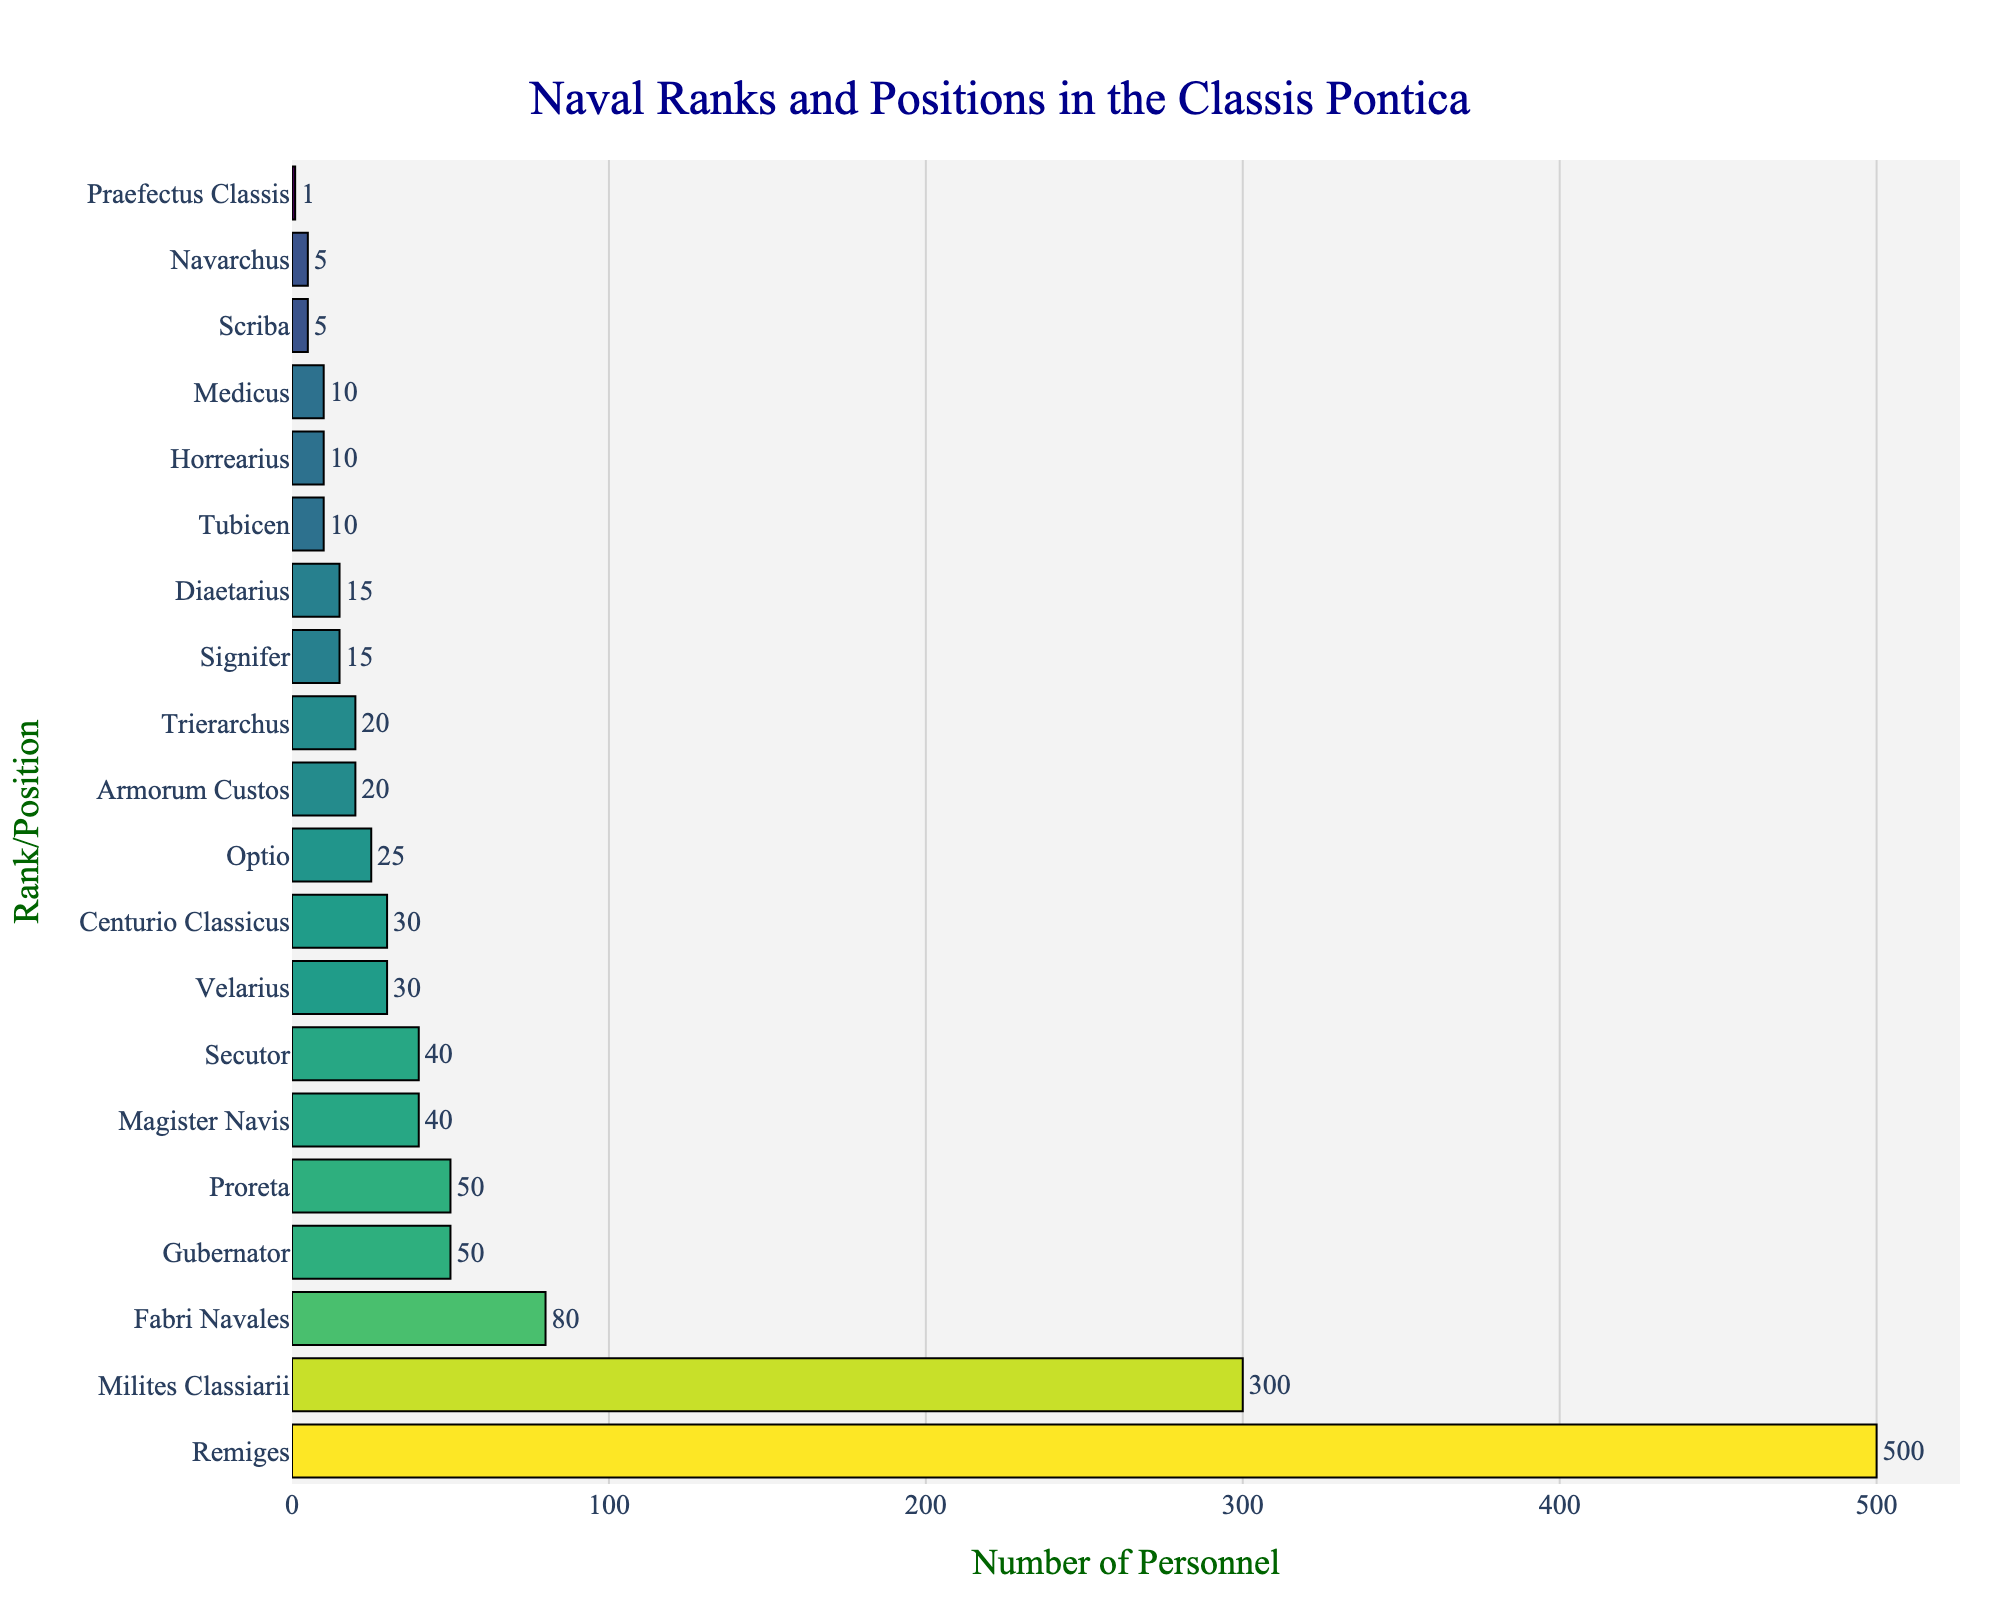What rank/position has the highest number of personnel? By looking at the lengths of the bars, the longest bar represents the rank/position with the highest number of personnel.
Answer: Remiges What is the total number of personnel represented in the chart? Summing up all the values from the different ranks/positions: 1 + 5 + 20 + 30 + 50 + 50 + 40 + 500 + 300 + 80 + 10 + 15 + 10 + 25 + 40 + 30 + 20 + 15 + 10 + 5 = 1,256.
Answer: 1,256 How many ranks/positions have fewer than 20 personnel? Identify the bars that correspond to values less than 20 and count them: Praefectus Classis (1), Scriba (5), Navarchus (5), Diaetarius (15), Signifer (15), and Medicus (10). These total 6 ranks/positions.
Answer: 6 Which rank/position has the closest number of personnel to that of the Gubernator? The Gubernator has 50 personnel. The two ranks/positions with personnel close to this number are Proreta (50) and Magister Navis (40). Since Proreta has the same number, it's the rank/position closest.
Answer: Proreta What is the average number of personnel for the ranks/positions with more than 100 personnel? Identify ranks/positions with more than 100 personnel: Remiges (500) and Milites Classiarii (300). Calculate the average: (500 + 300) / 2 = 800 / 2 = 400.
Answer: 400 Which ranks/positions have an equal number of personnel? Locate bars of the same length and identify the corresponding ranks/positions: Gubernator and Proreta both have 50 personnel.
Answer: Gubernator and Proreta How many times more personnel do the Remiges have compared to the Trierarchus? Divide the number of personnel of the Remiges by that of the Trierarchus: 500 / 20 = 25.
Answer: 25 What is the difference in the number of personnel between the Optio and the Fabri Navales? Subtract the number of personnel of the Optio (25) from that of the Fabri Navales (80): 80 - 25 = 55.
Answer: 55 Which rank/position is represented by the lightest color in the Viridis color scale? The lightest colors correspond to the lowest values. By visual inspection, the rank/position with the lightest color is Praefectus Classis with 1 personnel.
Answer: Praefectus Classis What is the ratio of the number of Milites Classiarii to the total number of Trierarchus, Centurio Classicus, and Optio combined? Calculate the combined personnel of Trierarchus (20), Centurio Classicus (30), and Optio (25): 20 + 30 + 25 = 75. The ratio is then 300 / 75 = 4.
Answer: 4 